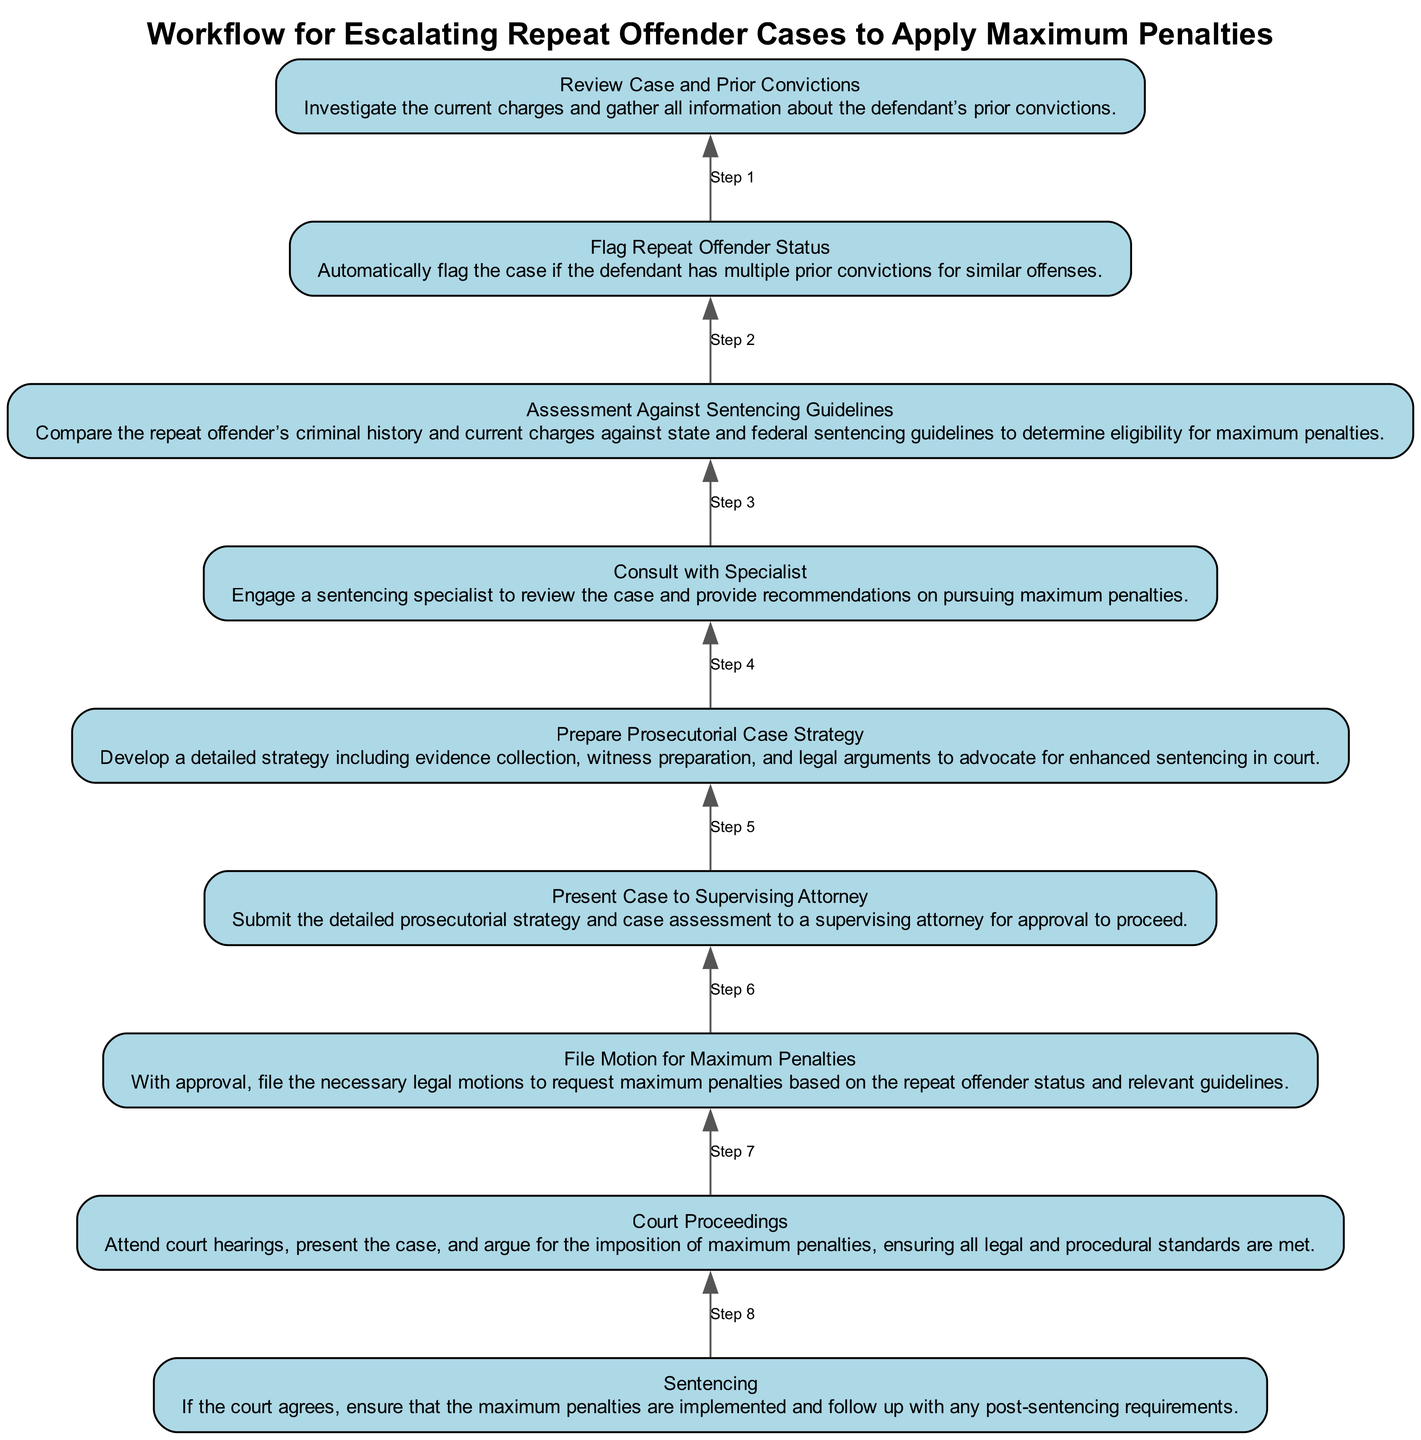What is the first step in the workflow? The first step, when following the flow from bottom to up, is to "Review Case and Prior Convictions". This indicates that the process starts with gathering information about the defendant's existing legal background.
Answer: Review Case and Prior Convictions How many steps are in the workflow? By counting the nodes shown in the diagram, there are a total of 9 steps outlined in the workflow. This includes each individual action from reviewing the case to sentencing.
Answer: 9 What does the final step in the workflow entail? The last step in the flowchart is "Sentencing", which means ensuring that the maximum penalties are implemented based on the court's agreement. This indicates the closure of the process.
Answer: Sentencing What step involves consulting with a specialist? The "Consult with Specialist" step focuses on engaging a sentencing specialist to offer insights and recommendations for pursuing maximum penalties, showing the importance of expert input.
Answer: Consult with Specialist What step comes before filing a motion for maximum penalties? Prior to "File Motion for Maximum Penalties", the workflow requires that the "Present Case to Supervising Attorney" step is completed, indicating the necessity of receiving approval from a supervising attorney first.
Answer: Present Case to Supervising Attorney Which step includes gathering further recommendations? The step "Consult with Specialist" is specifically about gathering further recommendations from a sentencing specialist after reviewing the case, emphasizing the need for expert consultation.
Answer: Consult with Specialist In which step is evidence collection included? "Prepare Prosecutorial Case Strategy" includes developing detailed strategies, which specifically entails evidence collection as a pivotal component of that preparation for court.
Answer: Prepare Prosecutorial Case Strategy What is the relationship between "Flag Repeat Offender Status" and "Assessment Against Sentencing Guidelines"? The "Flag Repeat Offender Status" step must be completed prior to "Assessment Against Sentencing Guidelines", as identifying the repeat offender status is essential for analyzing eligibility against specific penalties.
Answer: Sequential relationship, Flag Repeat Offender Status comes first 